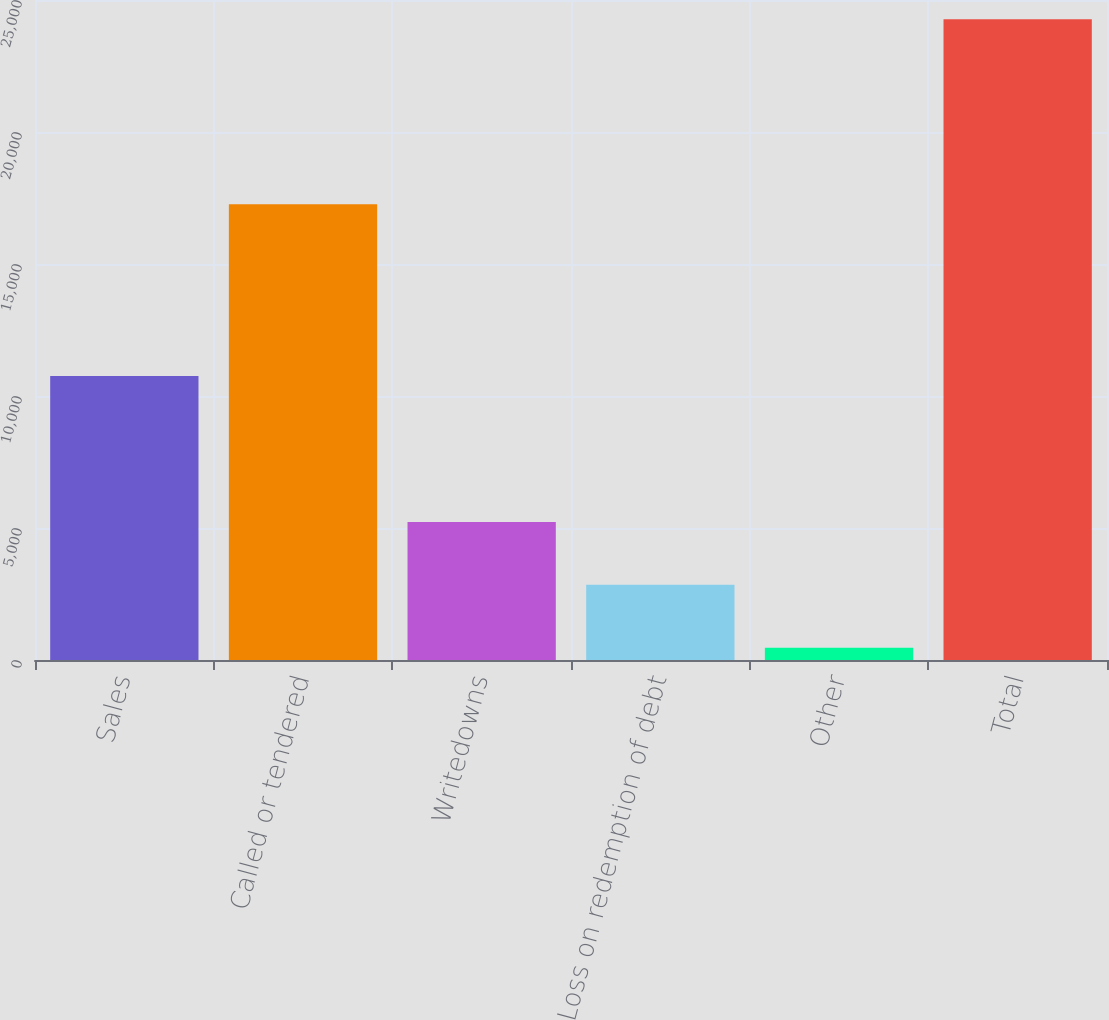Convert chart. <chart><loc_0><loc_0><loc_500><loc_500><bar_chart><fcel>Sales<fcel>Called or tendered<fcel>Writedowns<fcel>Loss on redemption of debt<fcel>Other<fcel>Total<nl><fcel>10761<fcel>17265<fcel>5226.8<fcel>2846.4<fcel>466<fcel>24270<nl></chart> 